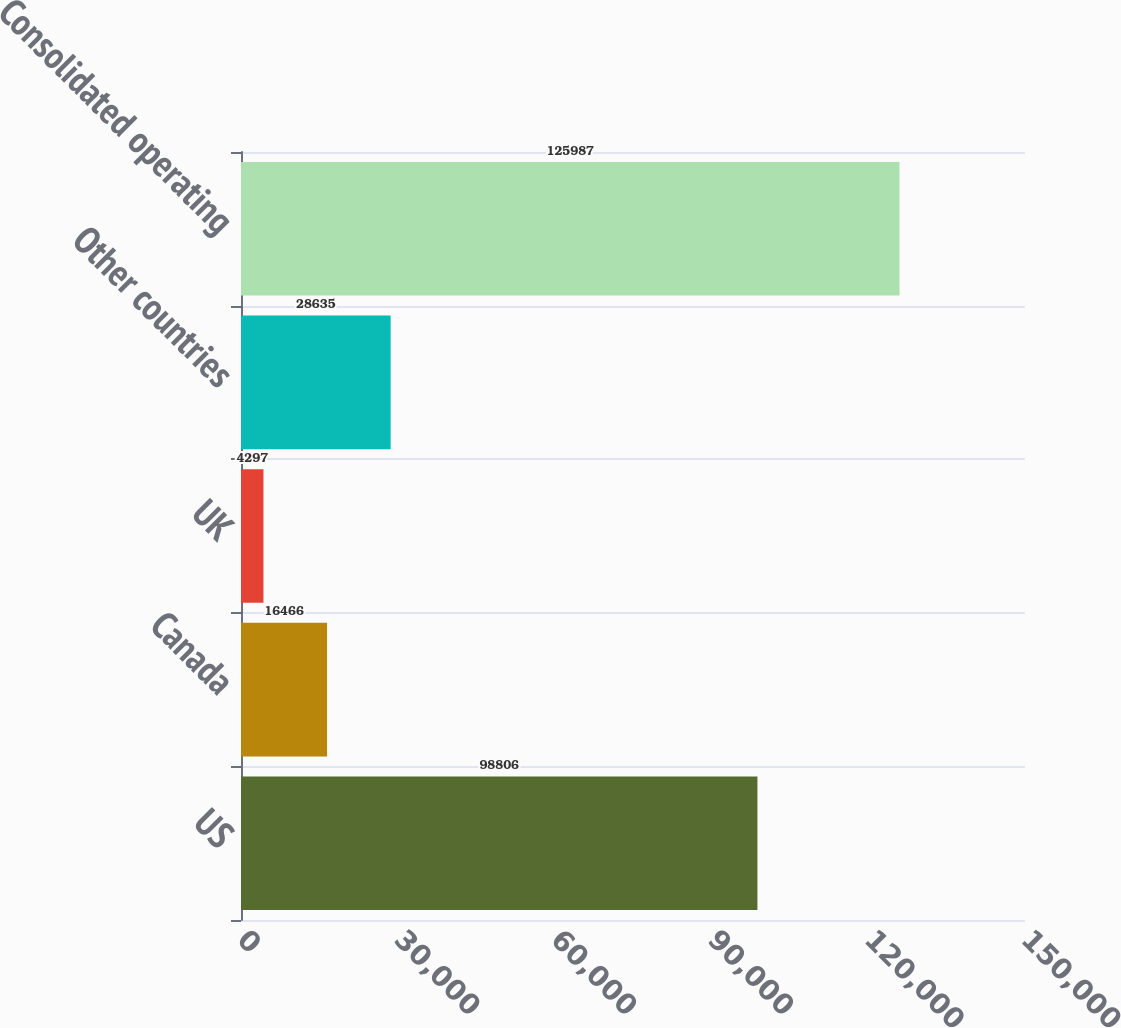Convert chart. <chart><loc_0><loc_0><loc_500><loc_500><bar_chart><fcel>US<fcel>Canada<fcel>UK<fcel>Other countries<fcel>Consolidated operating<nl><fcel>98806<fcel>16466<fcel>4297<fcel>28635<fcel>125987<nl></chart> 